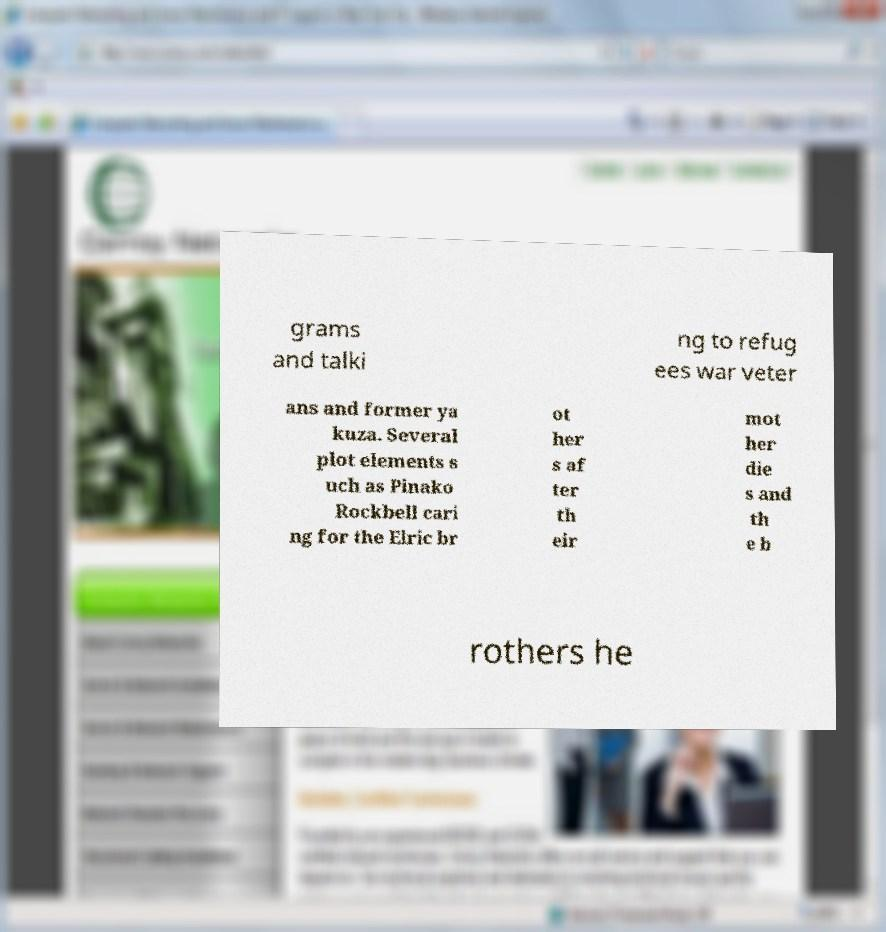I need the written content from this picture converted into text. Can you do that? grams and talki ng to refug ees war veter ans and former ya kuza. Several plot elements s uch as Pinako Rockbell cari ng for the Elric br ot her s af ter th eir mot her die s and th e b rothers he 